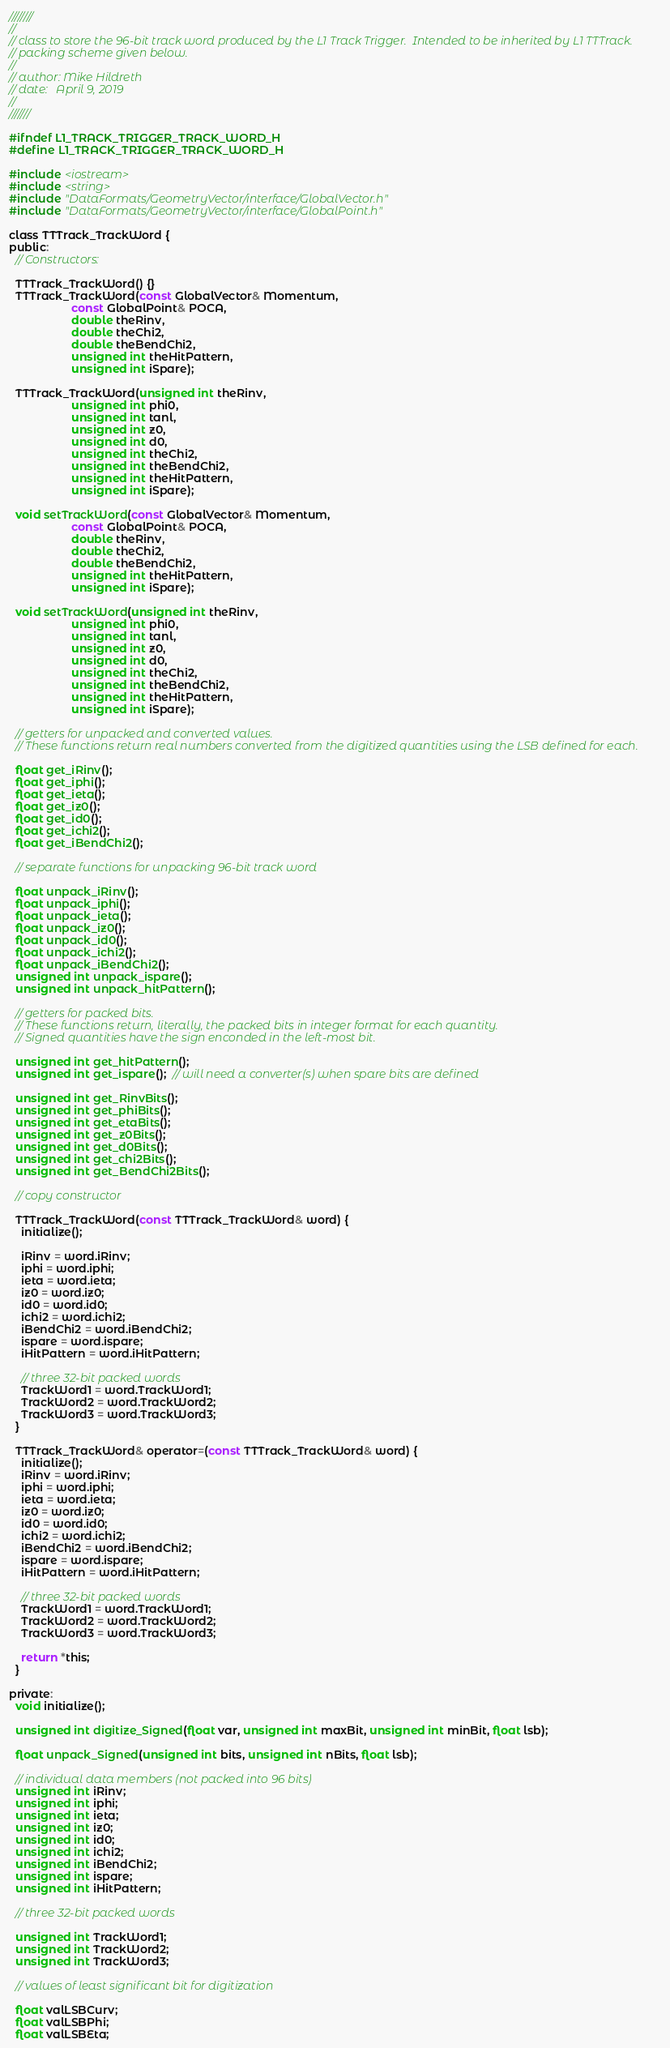<code> <loc_0><loc_0><loc_500><loc_500><_C_>////////
//
// class to store the 96-bit track word produced by the L1 Track Trigger.  Intended to be inherited by L1 TTTrack.
// packing scheme given below.
//
// author: Mike Hildreth
// date:   April 9, 2019
//
///////

#ifndef L1_TRACK_TRIGGER_TRACK_WORD_H
#define L1_TRACK_TRIGGER_TRACK_WORD_H

#include <iostream>
#include <string>
#include "DataFormats/GeometryVector/interface/GlobalVector.h"
#include "DataFormats/GeometryVector/interface/GlobalPoint.h"

class TTTrack_TrackWord {
public:
  // Constructors:

  TTTrack_TrackWord() {}
  TTTrack_TrackWord(const GlobalVector& Momentum,
                    const GlobalPoint& POCA,
                    double theRinv,
                    double theChi2,
                    double theBendChi2,
                    unsigned int theHitPattern,
                    unsigned int iSpare);

  TTTrack_TrackWord(unsigned int theRinv,
                    unsigned int phi0,
                    unsigned int tanl,
                    unsigned int z0,
                    unsigned int d0,
                    unsigned int theChi2,
                    unsigned int theBendChi2,
                    unsigned int theHitPattern,
                    unsigned int iSpare);

  void setTrackWord(const GlobalVector& Momentum,
                    const GlobalPoint& POCA,
                    double theRinv,
                    double theChi2,
                    double theBendChi2,
                    unsigned int theHitPattern,
                    unsigned int iSpare);

  void setTrackWord(unsigned int theRinv,
                    unsigned int phi0,
                    unsigned int tanl,
                    unsigned int z0,
                    unsigned int d0,
                    unsigned int theChi2,
                    unsigned int theBendChi2,
                    unsigned int theHitPattern,
                    unsigned int iSpare);

  // getters for unpacked and converted values.
  // These functions return real numbers converted from the digitized quantities using the LSB defined for each.

  float get_iRinv();
  float get_iphi();
  float get_ieta();
  float get_iz0();
  float get_id0();
  float get_ichi2();
  float get_iBendChi2();

  // separate functions for unpacking 96-bit track word

  float unpack_iRinv();
  float unpack_iphi();
  float unpack_ieta();
  float unpack_iz0();
  float unpack_id0();
  float unpack_ichi2();
  float unpack_iBendChi2();
  unsigned int unpack_ispare();
  unsigned int unpack_hitPattern();

  // getters for packed bits.
  // These functions return, literally, the packed bits in integer format for each quantity.
  // Signed quantities have the sign enconded in the left-most bit.

  unsigned int get_hitPattern();
  unsigned int get_ispare();  // will need a converter(s) when spare bits are defined

  unsigned int get_RinvBits();
  unsigned int get_phiBits();
  unsigned int get_etaBits();
  unsigned int get_z0Bits();
  unsigned int get_d0Bits();
  unsigned int get_chi2Bits();
  unsigned int get_BendChi2Bits();

  // copy constructor

  TTTrack_TrackWord(const TTTrack_TrackWord& word) {
    initialize();

    iRinv = word.iRinv;
    iphi = word.iphi;
    ieta = word.ieta;
    iz0 = word.iz0;
    id0 = word.id0;
    ichi2 = word.ichi2;
    iBendChi2 = word.iBendChi2;
    ispare = word.ispare;
    iHitPattern = word.iHitPattern;

    // three 32-bit packed words
    TrackWord1 = word.TrackWord1;
    TrackWord2 = word.TrackWord2;
    TrackWord3 = word.TrackWord3;
  }

  TTTrack_TrackWord& operator=(const TTTrack_TrackWord& word) {
    initialize();
    iRinv = word.iRinv;
    iphi = word.iphi;
    ieta = word.ieta;
    iz0 = word.iz0;
    id0 = word.id0;
    ichi2 = word.ichi2;
    iBendChi2 = word.iBendChi2;
    ispare = word.ispare;
    iHitPattern = word.iHitPattern;

    // three 32-bit packed words
    TrackWord1 = word.TrackWord1;
    TrackWord2 = word.TrackWord2;
    TrackWord3 = word.TrackWord3;

    return *this;
  }

private:
  void initialize();

  unsigned int digitize_Signed(float var, unsigned int maxBit, unsigned int minBit, float lsb);

  float unpack_Signed(unsigned int bits, unsigned int nBits, float lsb);

  // individual data members (not packed into 96 bits)
  unsigned int iRinv;
  unsigned int iphi;
  unsigned int ieta;
  unsigned int iz0;
  unsigned int id0;
  unsigned int ichi2;
  unsigned int iBendChi2;
  unsigned int ispare;
  unsigned int iHitPattern;

  // three 32-bit packed words

  unsigned int TrackWord1;
  unsigned int TrackWord2;
  unsigned int TrackWord3;

  // values of least significant bit for digitization

  float valLSBCurv;
  float valLSBPhi;
  float valLSBEta;</code> 